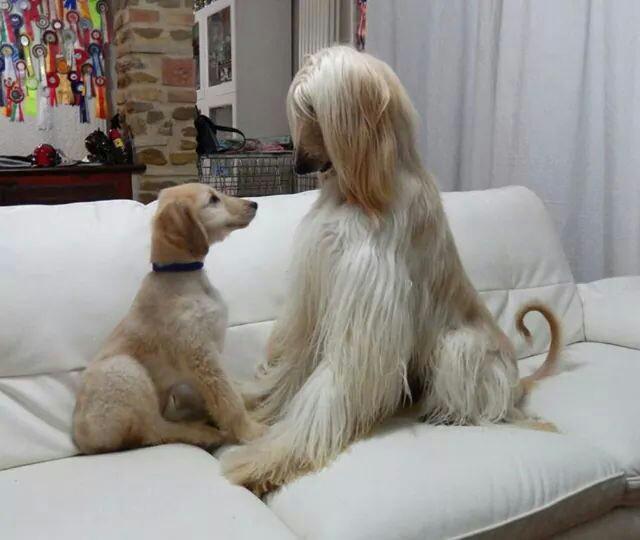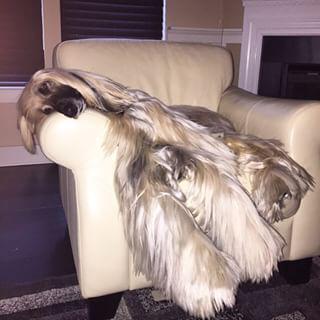The first image is the image on the left, the second image is the image on the right. Analyze the images presented: Is the assertion "One image shows a single afghan hound lying on a soft material with a print pattern in the scene, and the other image shows one forward-facing afghan with parted hair." valid? Answer yes or no. No. The first image is the image on the left, the second image is the image on the right. For the images displayed, is the sentence "One dog is standing and one dog is laying down." factually correct? Answer yes or no. No. 